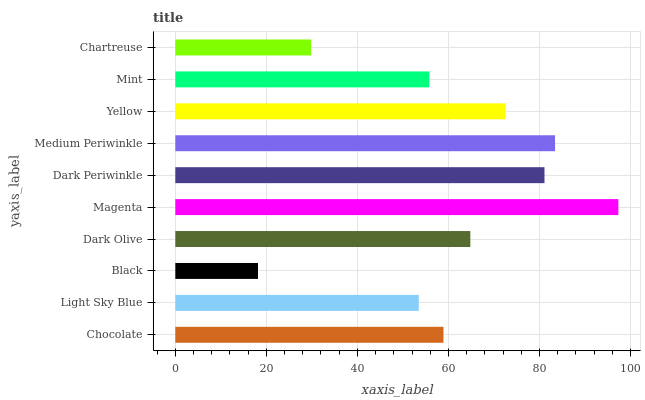Is Black the minimum?
Answer yes or no. Yes. Is Magenta the maximum?
Answer yes or no. Yes. Is Light Sky Blue the minimum?
Answer yes or no. No. Is Light Sky Blue the maximum?
Answer yes or no. No. Is Chocolate greater than Light Sky Blue?
Answer yes or no. Yes. Is Light Sky Blue less than Chocolate?
Answer yes or no. Yes. Is Light Sky Blue greater than Chocolate?
Answer yes or no. No. Is Chocolate less than Light Sky Blue?
Answer yes or no. No. Is Dark Olive the high median?
Answer yes or no. Yes. Is Chocolate the low median?
Answer yes or no. Yes. Is Chartreuse the high median?
Answer yes or no. No. Is Mint the low median?
Answer yes or no. No. 